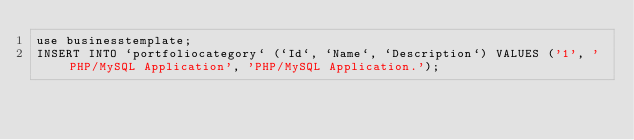Convert code to text. <code><loc_0><loc_0><loc_500><loc_500><_SQL_>use businesstemplate;
INSERT INTO `portfoliocategory` (`Id`, `Name`, `Description`) VALUES ('1', 'PHP/MySQL Application', 'PHP/MySQL Application.');</code> 